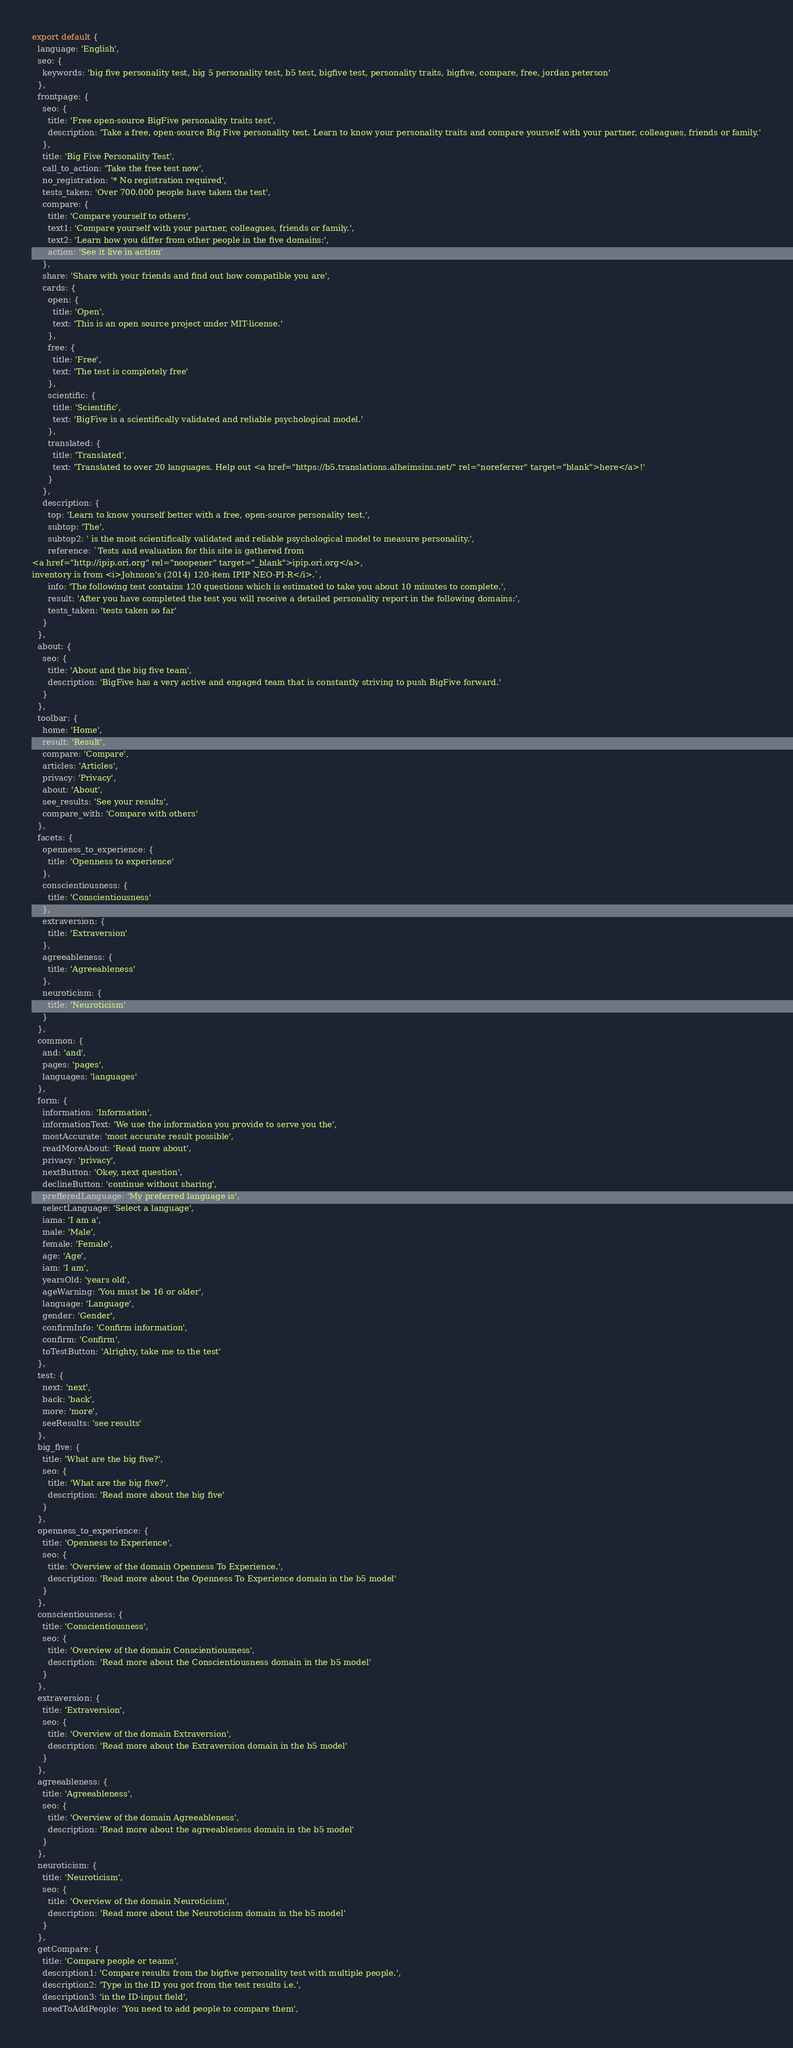<code> <loc_0><loc_0><loc_500><loc_500><_JavaScript_>export default {
  language: 'English',
  seo: {
    keywords: 'big five personality test, big 5 personality test, b5 test, bigfive test, personality traits, bigfive, compare, free, jordan peterson'
  },
  frontpage: {
    seo: {
      title: 'Free open-source BigFive personality traits test',
      description: 'Take a free, open-source Big Five personality test. Learn to know your personality traits and compare yourself with your partner, colleagues, friends or family.'
    },
    title: 'Big Five Personality Test',
    call_to_action: 'Take the free test now',
    no_registration: '* No registration required',
    tests_taken: 'Over 700.000 people have taken the test',
    compare: {
      title: 'Compare yourself to others',
      text1: 'Compare yourself with your partner, colleagues, friends or family.',
      text2: 'Learn how you differ from other people in the five domains:',
      action: 'See it live in action'
    },
    share: 'Share with your friends and find out how compatible you are',
    cards: {
      open: {
        title: 'Open',
        text: 'This is an open source project under MIT-license.'
      },
      free: {
        title: 'Free',
        text: 'The test is completely free'
      },
      scientific: {
        title: 'Scientific',
        text: 'BigFive is a scientifically validated and reliable psychological model.'
      },
      translated: {
        title: 'Translated',
        text: 'Translated to over 20 languages. Help out <a href="https://b5.translations.alheimsins.net/" rel="noreferrer" target="blank">here</a>!'
      }
    },
    description: {
      top: 'Learn to know yourself better with a free, open-source personality test.',
      subtop: 'The',
      subtop2: ' is the most scientifically validated and reliable psychological model to measure personality.',
      reference: `Tests and evaluation for this site is gathered from
<a href="http://ipip.ori.org" rel="noopener" target="_blank">ipip.ori.org</a>,
inventory is from <i>Johnson's (2014) 120-item IPIP NEO-PI-R</i>.`,
      info: 'The following test contains 120 questions which is estimated to take you about 10 minutes to complete.',
      result: 'After you have completed the test you will receive a detailed personality report in the following domains:',
      tests_taken: 'tests taken so far'
    }
  },
  about: {
    seo: {
      title: 'About and the big five team',
      description: 'BigFive has a very active and engaged team that is constantly striving to push BigFive forward.'
    }
  },
  toolbar: {
    home: 'Home',
    result: 'Result',
    compare: 'Compare',
    articles: 'Articles',
    privacy: 'Privacy',
    about: 'About',
    see_results: 'See your results',
    compare_with: 'Compare with others'
  },
  facets: {
    openness_to_experience: {
      title: 'Openness to experience'
    },
    conscientiousness: {
      title: 'Conscientiousness'
    },
    extraversion: {
      title: 'Extraversion'
    },
    agreeableness: {
      title: 'Agreeableness'
    },
    neuroticism: {
      title: 'Neuroticism'
    }
  },
  common: {
    and: 'and',
    pages: 'pages',
    languages: 'languages'
  },
  form: {
    information: 'Information',
    informationText: 'We use the information you provide to serve you the',
    mostAccurate: 'most accurate result possible',
    readMoreAbout: 'Read more about',
    privacy: 'privacy',
    nextButton: 'Okey, next question',
    declineButton: 'continue without sharing',
    prefferedLanguage: 'My preferred language is',
    selectLanguage: 'Select a language',
    iama: 'I am a',
    male: 'Male',
    female: 'Female',
    age: 'Age',
    iam: 'I am',
    yearsOld: 'years old',
    ageWarning: 'You must be 16 or older',
    language: 'Language',
    gender: 'Gender',
    confirmInfo: 'Confirm information',
    confirm: 'Confirm',
    toTestButton: 'Alrighty, take me to the test'
  },
  test: {
    next: 'next',
    back: 'back',
    more: 'more',
    seeResults: 'see results'
  },
  big_five: {
    title: 'What are the big five?',
    seo: {
      title: 'What are the big five?',
      description: 'Read more about the big five'
    }
  },
  openness_to_experience: {
    title: 'Openness to Experience',
    seo: {
      title: 'Overview of the domain Openness To Experience.',
      description: 'Read more about the Openness To Experience domain in the b5 model'
    }
  },
  conscientiousness: {
    title: 'Conscientiousness',
    seo: {
      title: 'Overview of the domain Conscientiousness',
      description: 'Read more about the Conscientiousness domain in the b5 model'
    }
  },
  extraversion: {
    title: 'Extraversion',
    seo: {
      title: 'Overview of the domain Extraversion',
      description: 'Read more about the Extraversion domain in the b5 model'
    }
  },
  agreeableness: {
    title: 'Agreeableness',
    seo: {
      title: 'Overview of the domain Agreeableness',
      description: 'Read more about the agreeableness domain in the b5 model'
    }
  },
  neuroticism: {
    title: 'Neuroticism',
    seo: {
      title: 'Overview of the domain Neuroticism',
      description: 'Read more about the Neuroticism domain in the b5 model'
    }
  },
  getCompare: {
    title: 'Compare people or teams',
    description1: 'Compare results from the bigfive personality test with multiple people.',
    description2: 'Type in the ID you got from the test results i.e.',
    description3: 'in the ID-input field',
    needToAddPeople: 'You need to add people to compare them',</code> 